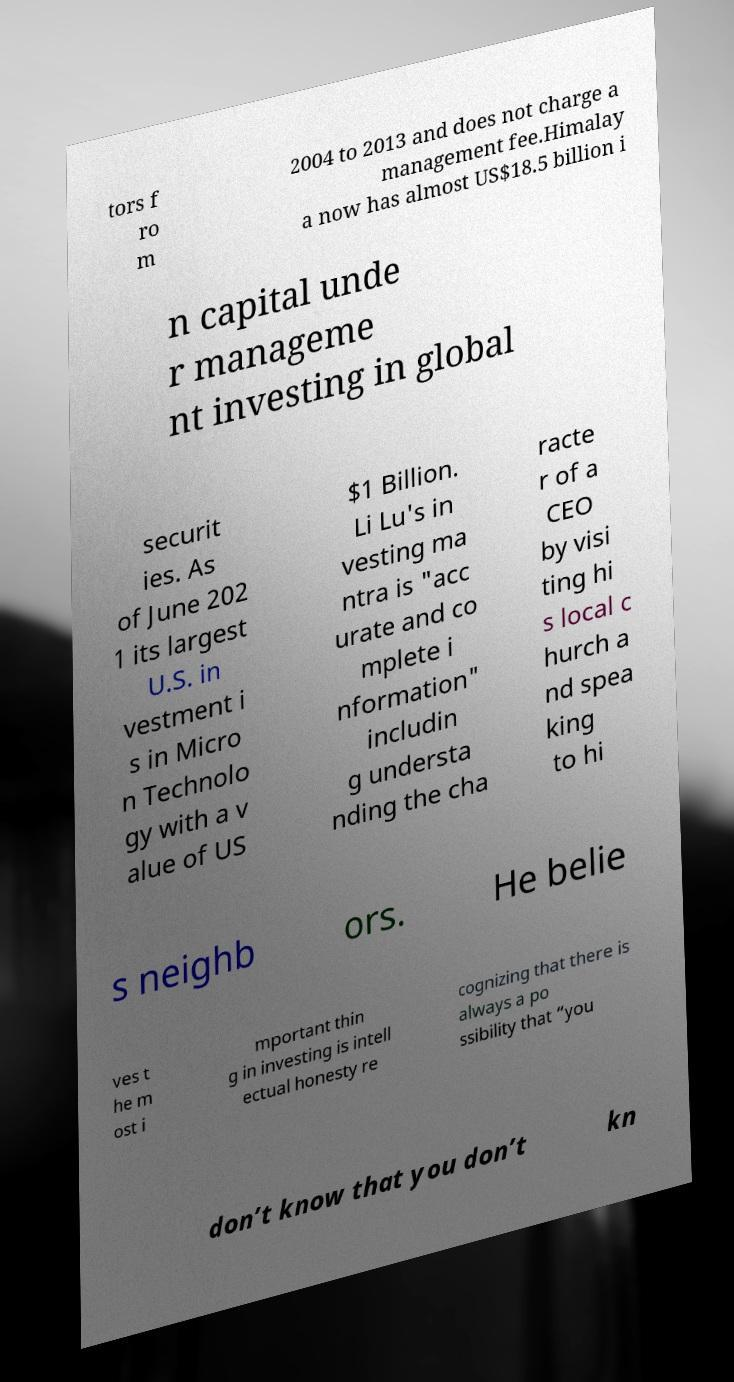There's text embedded in this image that I need extracted. Can you transcribe it verbatim? tors f ro m 2004 to 2013 and does not charge a management fee.Himalay a now has almost US$18.5 billion i n capital unde r manageme nt investing in global securit ies. As of June 202 1 its largest U.S. in vestment i s in Micro n Technolo gy with a v alue of US $1 Billion. Li Lu's in vesting ma ntra is "acc urate and co mplete i nformation" includin g understa nding the cha racte r of a CEO by visi ting hi s local c hurch a nd spea king to hi s neighb ors. He belie ves t he m ost i mportant thin g in investing is intell ectual honesty re cognizing that there is always a po ssibility that “you don’t know that you don’t kn 